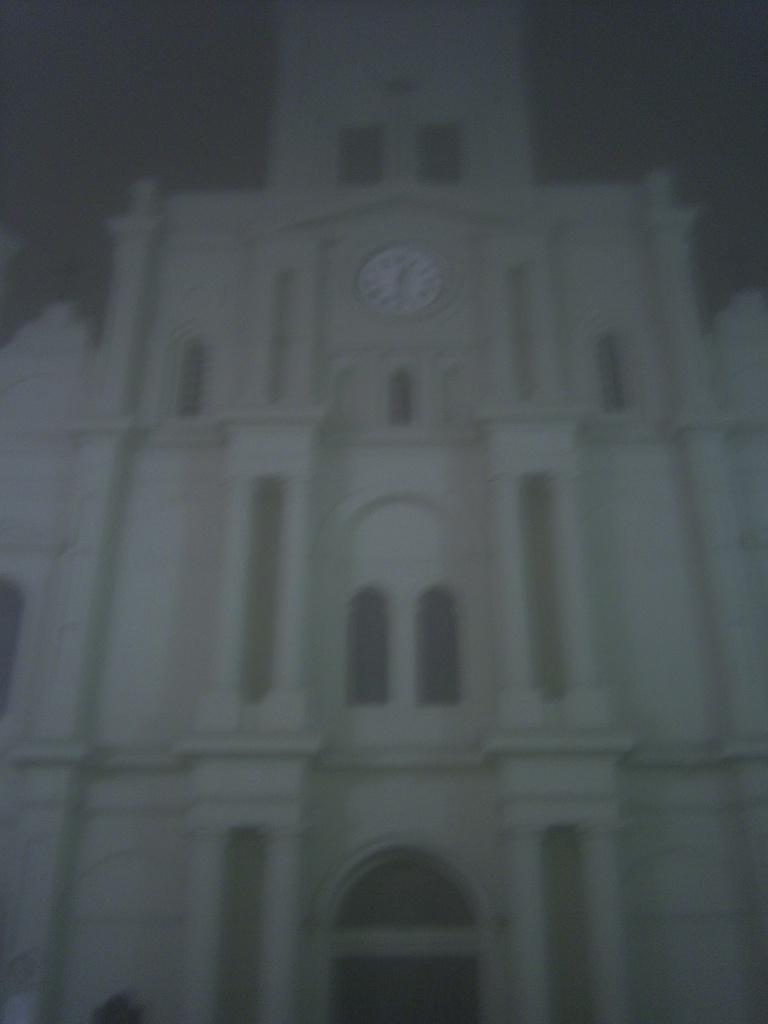What type of structure is present in the image? There is a building in the image. What object is featured in the image that is typically used for measuring time? There is a clock in the image. What is the color of the background in the image? The background of the image is dark. What type of quiet voyage is depicted in the image? There is no voyage or any reference to a quiet voyage in the image; it features a building and a clock. How does the clock roll in the image? The clock does not roll in the image; it is stationary and used for measuring time. 